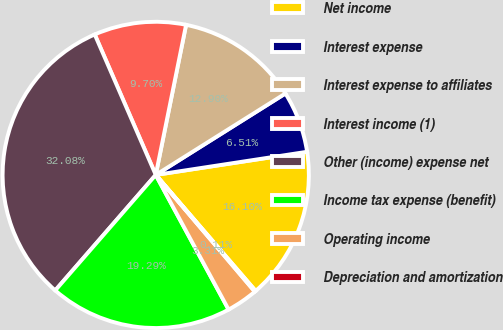Convert chart to OTSL. <chart><loc_0><loc_0><loc_500><loc_500><pie_chart><fcel>Net income<fcel>Interest expense<fcel>Interest expense to affiliates<fcel>Interest income (1)<fcel>Other (income) expense net<fcel>Income tax expense (benefit)<fcel>Operating income<fcel>Depreciation and amortization<nl><fcel>16.1%<fcel>6.51%<fcel>12.9%<fcel>9.7%<fcel>32.08%<fcel>19.29%<fcel>3.31%<fcel>0.11%<nl></chart> 